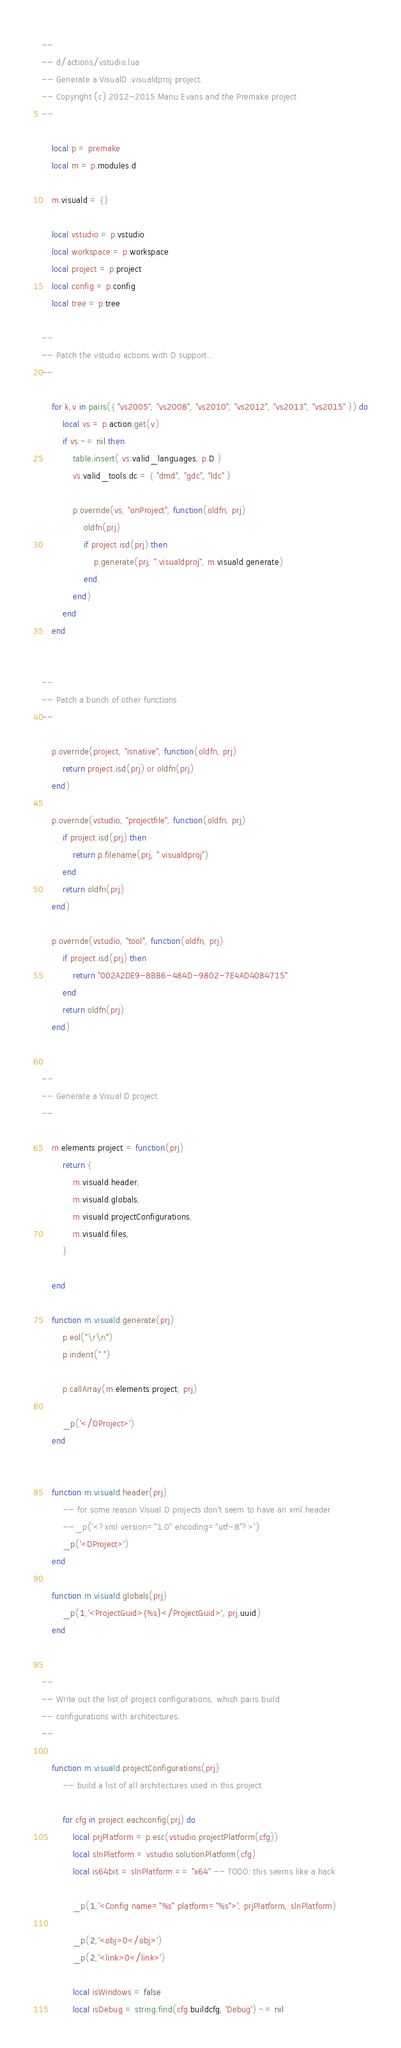Convert code to text. <code><loc_0><loc_0><loc_500><loc_500><_Lua_>--
-- d/actions/vstudio.lua
-- Generate a VisualD .visualdproj project.
-- Copyright (c) 2012-2015 Manu Evans and the Premake project
--

	local p = premake
	local m = p.modules.d

	m.visuald = {}

	local vstudio = p.vstudio
	local workspace = p.workspace
	local project = p.project
	local config = p.config
	local tree = p.tree

--
-- Patch the vstudio actions with D support...
--

	for k,v in pairs({ "vs2005", "vs2008", "vs2010", "vs2012", "vs2013", "vs2015" }) do
		local vs = p.action.get(v)
		if vs ~= nil then
			table.insert( vs.valid_languages, p.D )
			vs.valid_tools.dc = { "dmd", "gdc", "ldc" }

			p.override(vs, "onProject", function(oldfn, prj)
				oldfn(prj)
				if project.isd(prj) then
					p.generate(prj, ".visualdproj", m.visuald.generate)
				end
			end)
		end
	end


--
-- Patch a bunch of other functions
--

	p.override(project, "isnative", function(oldfn, prj)
		return project.isd(prj) or oldfn(prj)
	end)

	p.override(vstudio, "projectfile", function(oldfn, prj)
		if project.isd(prj) then
			return p.filename(prj, ".visualdproj")
		end
		return oldfn(prj)
	end)

	p.override(vstudio, "tool", function(oldfn, prj)
		if project.isd(prj) then
			return "002A2DE9-8BB6-484D-9802-7E4AD4084715"
		end
		return oldfn(prj)
	end)


--
-- Generate a Visual D project.
--

	m.elements.project = function(prj)
		return {
			m.visuald.header,
			m.visuald.globals,
			m.visuald.projectConfigurations,
			m.visuald.files,
		}

	end

	function m.visuald.generate(prj)
		p.eol("\r\n")
		p.indent(" ")

		p.callArray(m.elements.project, prj)

		_p('</DProject>')
	end


	function m.visuald.header(prj)
		-- for some reason Visual D projects don't seem to have an xml header
		--_p('<?xml version="1.0" encoding="utf-8"?>')
		_p('<DProject>')
	end

	function m.visuald.globals(prj)
		_p(1,'<ProjectGuid>{%s}</ProjectGuid>', prj.uuid)
	end


--
-- Write out the list of project configurations, which pairs build
-- configurations with architectures.
--

	function m.visuald.projectConfigurations(prj)
		-- build a list of all architectures used in this project

		for cfg in project.eachconfig(prj) do
			local prjPlatform = p.esc(vstudio.projectPlatform(cfg))
			local slnPlatform = vstudio.solutionPlatform(cfg)
			local is64bit = slnPlatform == "x64" -- TODO: this seems like a hack

			_p(1,'<Config name="%s" platform="%s">', prjPlatform, slnPlatform)

			_p(2,'<obj>0</obj>')
			_p(2,'<link>0</link>')

			local isWindows = false
			local isDebug = string.find(cfg.buildcfg, 'Debug') ~= nil</code> 